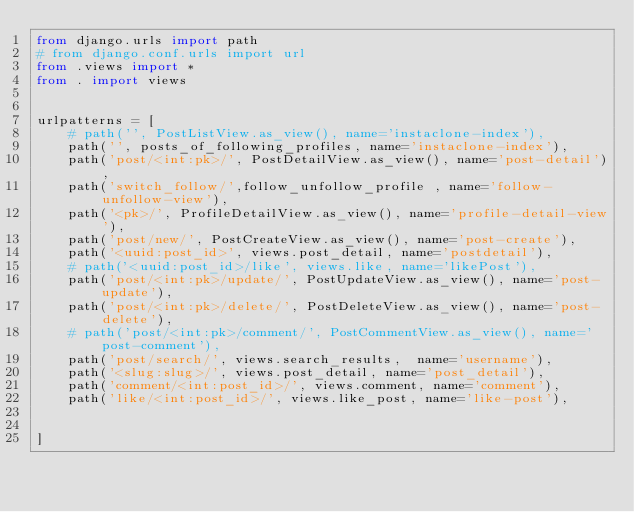<code> <loc_0><loc_0><loc_500><loc_500><_Python_>from django.urls import path
# from django.conf.urls import url
from .views import *
from . import views


urlpatterns = [
    # path('', PostListView.as_view(), name='instaclone-index'),
    path('', posts_of_following_profiles, name='instaclone-index'),
    path('post/<int:pk>/', PostDetailView.as_view(), name='post-detail'),
    path('switch_follow/',follow_unfollow_profile , name='follow-unfollow-view'),
    path('<pk>/', ProfileDetailView.as_view(), name='profile-detail-view'),
    path('post/new/', PostCreateView.as_view(), name='post-create'),
    path('<uuid:post_id>', views.post_detail, name='postdetail'),
    # path('<uuid:post_id>/like', views.like, name='likePost'),
    path('post/<int:pk>/update/', PostUpdateView.as_view(), name='post-update'),
    path('post/<int:pk>/delete/', PostDeleteView.as_view(), name='post-delete'),
    # path('post/<int:pk>/comment/', PostCommentView.as_view(), name='post-comment'),
    path('post/search/', views.search_results,  name='username'),
    path('<slug:slug>/', views.post_detail, name='post_detail'),
    path('comment/<int:post_id>/', views.comment, name='comment'),
    path('like/<int:post_id>/', views.like_post, name='like-post'),
    

]      
</code> 